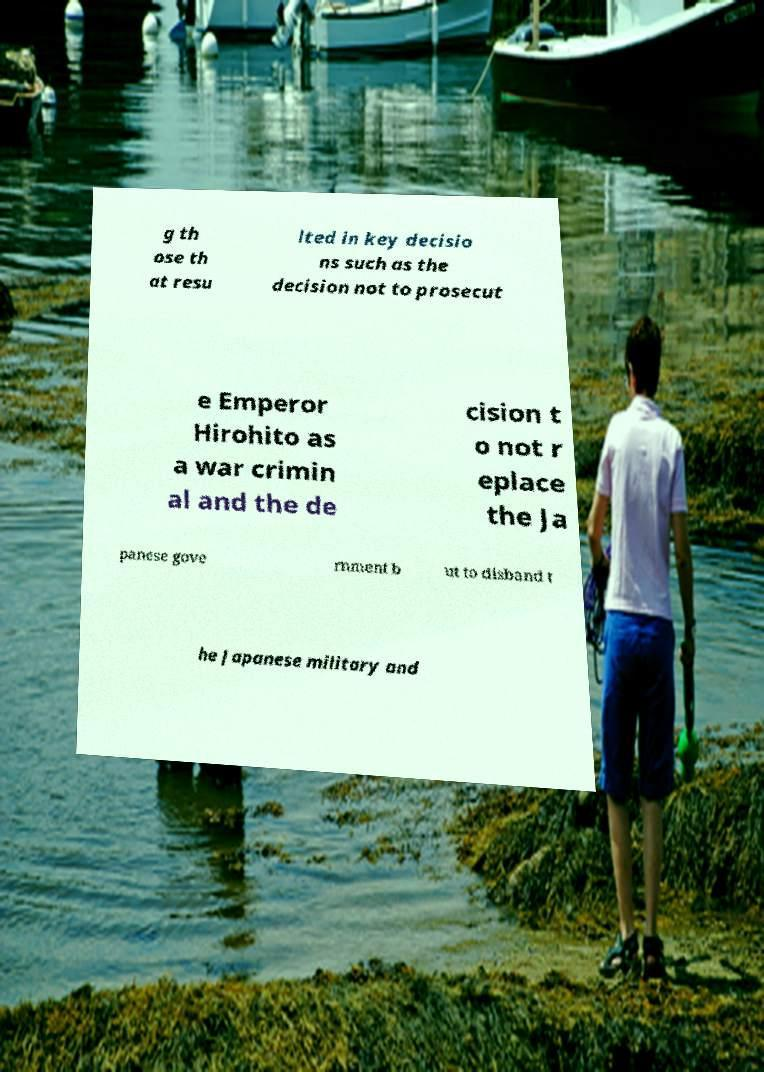Can you read and provide the text displayed in the image?This photo seems to have some interesting text. Can you extract and type it out for me? g th ose th at resu lted in key decisio ns such as the decision not to prosecut e Emperor Hirohito as a war crimin al and the de cision t o not r eplace the Ja panese gove rnment b ut to disband t he Japanese military and 